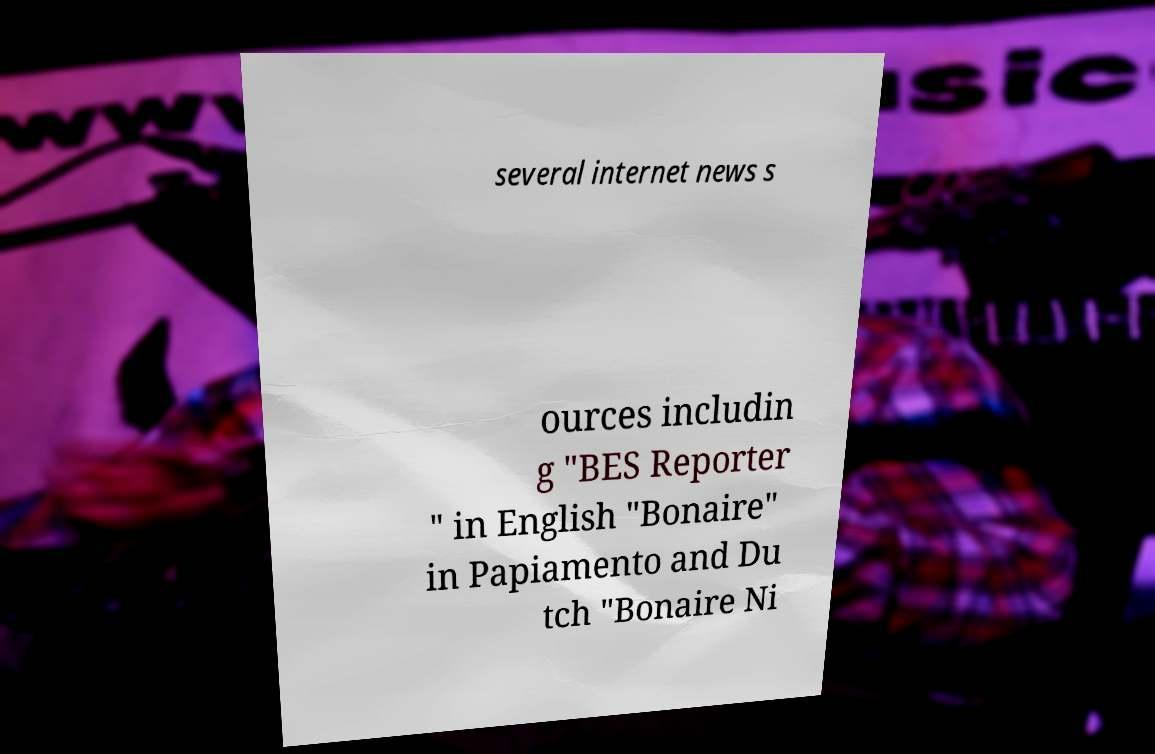Can you accurately transcribe the text from the provided image for me? several internet news s ources includin g "BES Reporter " in English "Bonaire" in Papiamento and Du tch "Bonaire Ni 